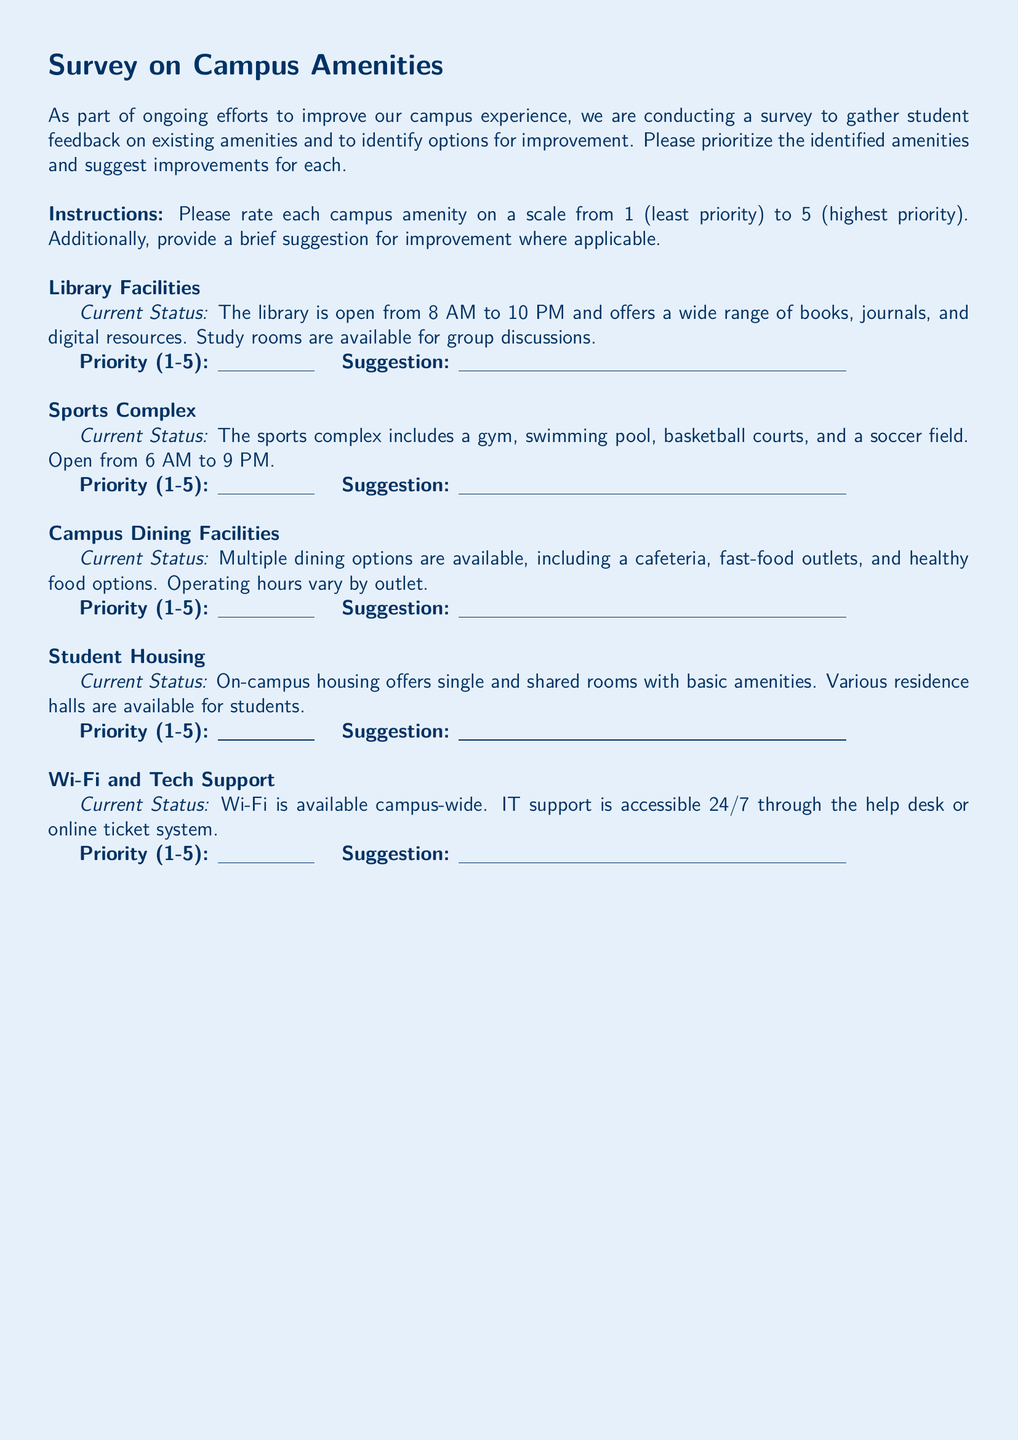What are the operating hours of the library? The document states that the library is open from 8 AM to 10 PM.
Answer: 8 AM to 10 PM What facilities are included in the sports complex? The amenities mentioned in the document for the sports complex include a gym, swimming pool, basketball courts, and a soccer field.
Answer: Gym, swimming pool, basketball courts, and a soccer field How many types of dining options are there on campus? The document references multiple dining options, suggesting at least three different types: a cafeteria, fast-food outlets, and healthy food options.
Answer: Multiple What is the operation time of the sports complex? The document indicates that the sports complex operates from 6 AM to 9 PM.
Answer: 6 AM to 9 PM What is the current status of student housing facilities? The document describes student housing as offering single and shared rooms with basic amenities, across various residence halls.
Answer: Basic amenities Is IT support available 24/7? The document mentions that IT support is accessible 24/7 through the help desk or online ticket system, confirming its availability.
Answer: Yes What does the document encourage students to provide? The document encourages students to provide feedback on existing amenities and suggestions for improvement, requesting their input for enhancements.
Answer: Suggestions for improvement How should students rate each campus amenity? According to the document, students should rate each amenity on a scale from 1 (least priority) to 5 (highest priority).
Answer: 1 to 5 What is the purpose of the survey mentioned in the document? The document states that the purpose of the survey is to gather student feedback on existing amenities and to identify options for improvement.
Answer: Gather student feedback 